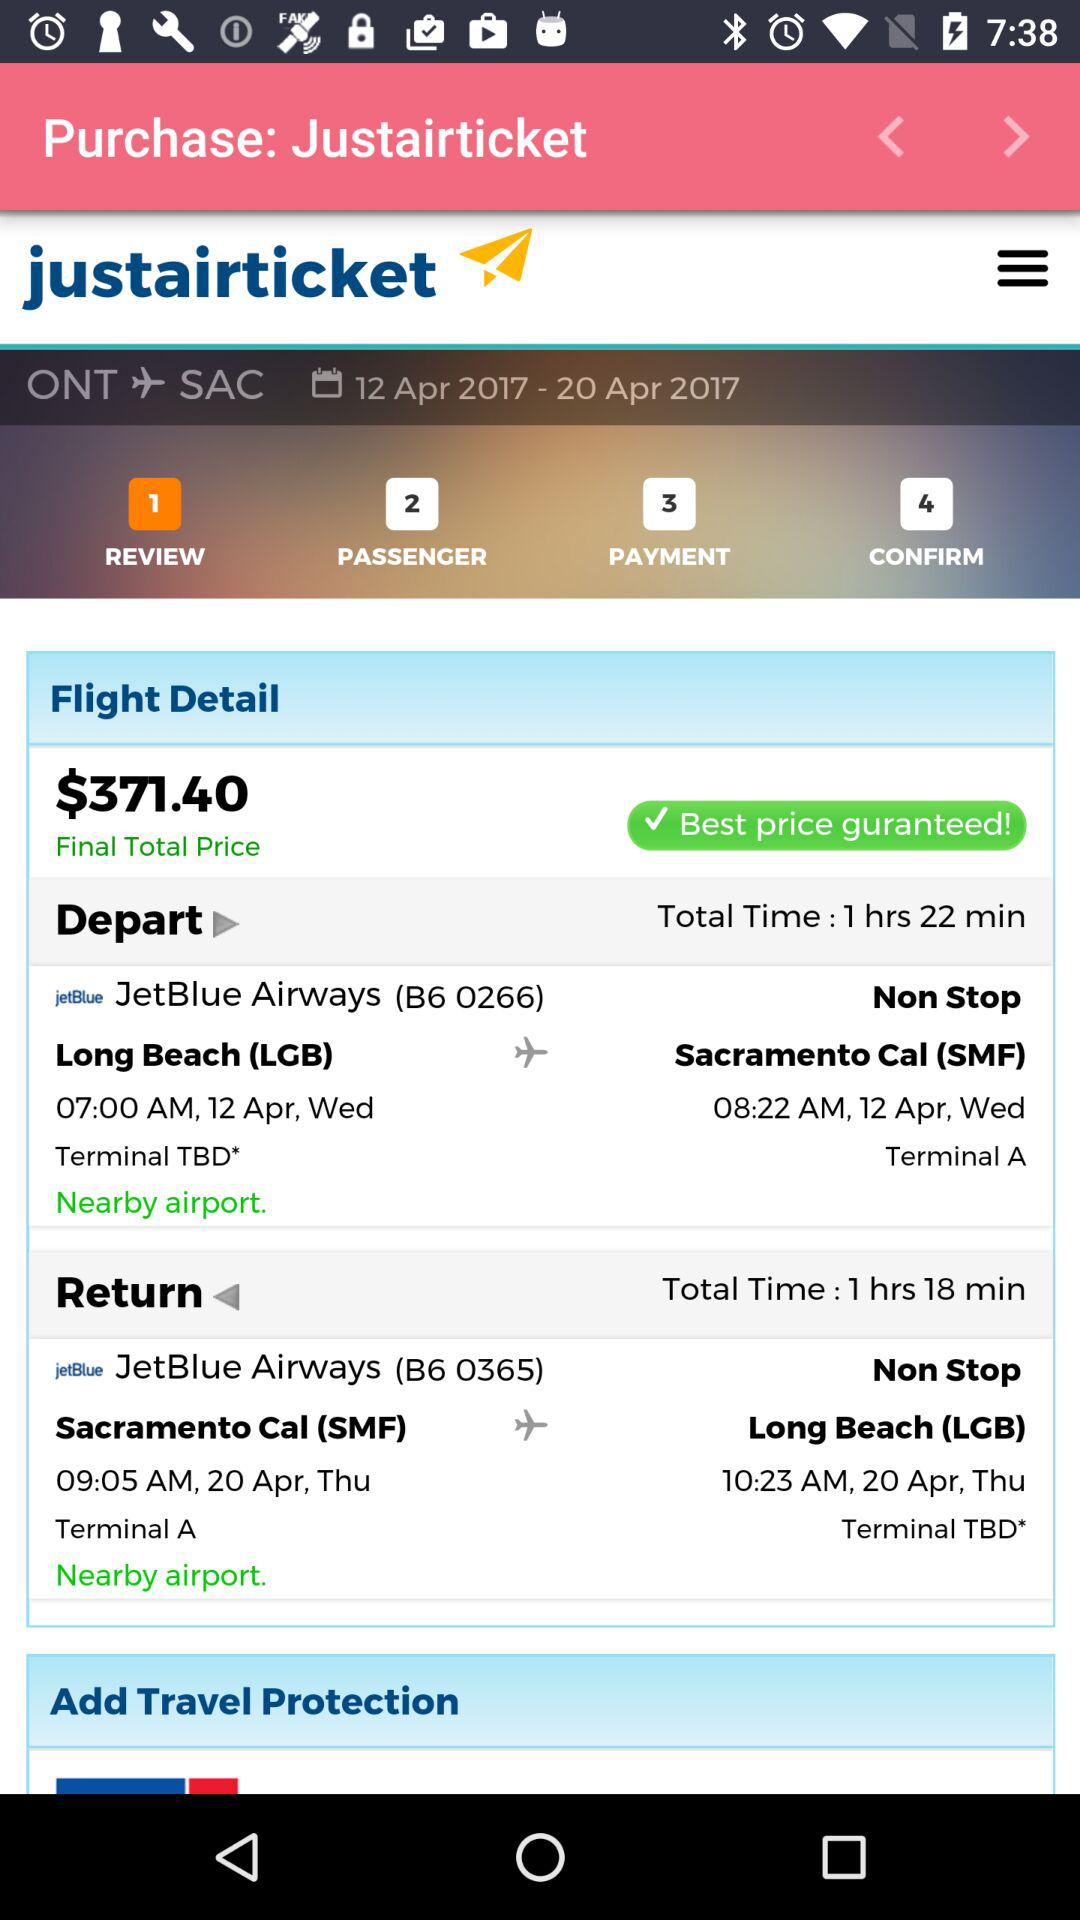What is the total travel time from LGB to SMF? The total travel time from LGB to SMF is 1 hour and 22 minutes. 